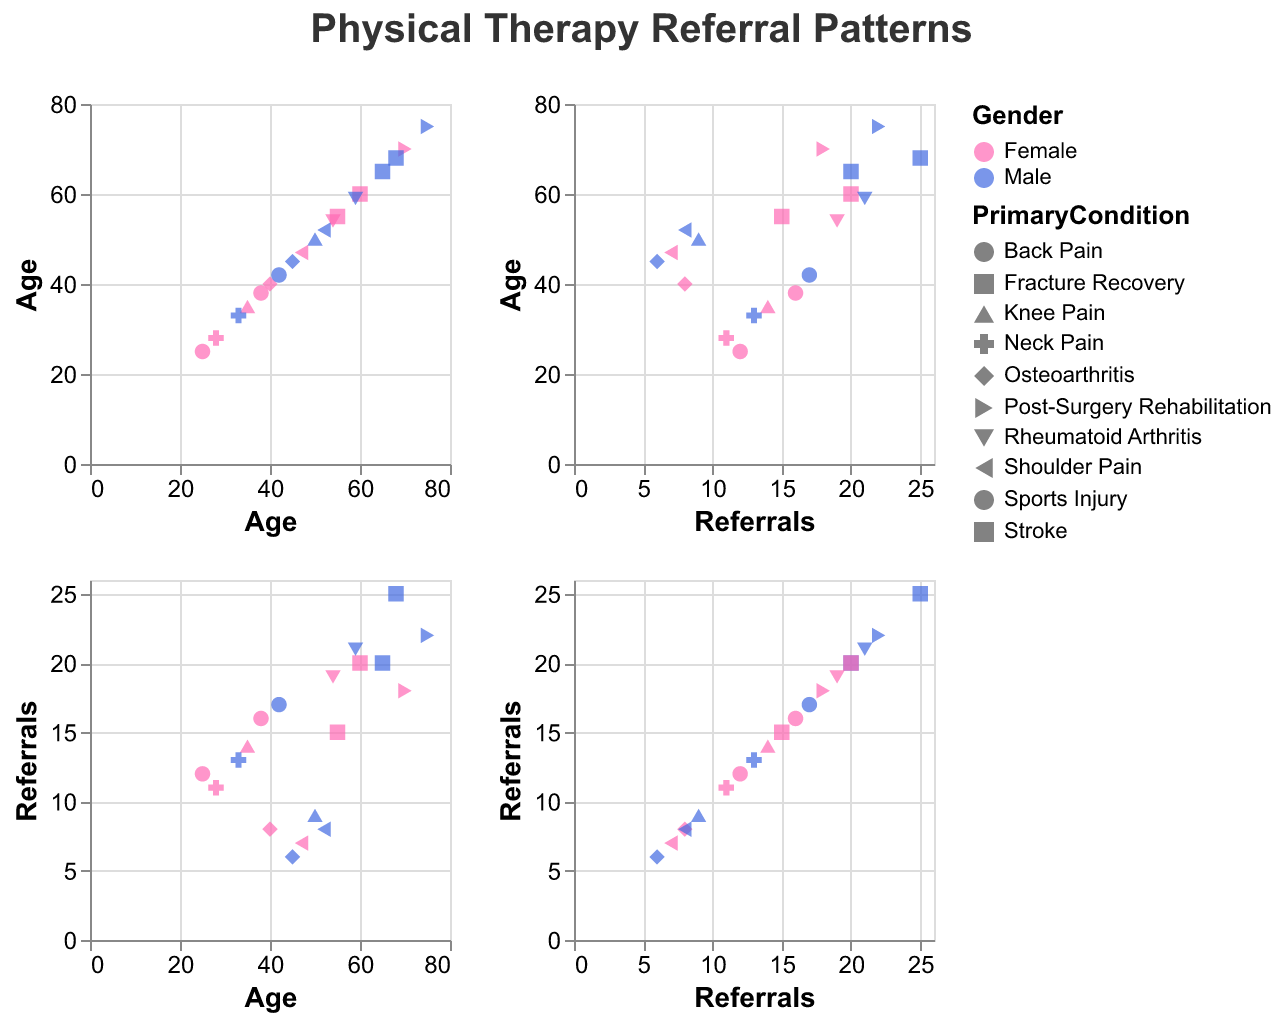What are the axis labels of the scatter plot matrix? The scatter plot matrix has axes labeled as "Age" and "Referrals" because the figure is created with these two variables to show the relationship between different features.
Answer: Age and Referrals How many data points are there in the scatter plot matrix? The data has 20 rows, which means there are 20 data points representing different individuals' ages, genders, primary conditions, and referrals.
Answer: 20 What is the title of the scatter plot matrix? The title of the scatter plot matrix can be seen at the top of the figure, which indicates what the visualization is about.
Answer: Physical Therapy Referral Patterns How is gender represented in the scatter plot matrix? Gender is represented by color in the scatter plot matrix. Females are in pink, and males are in blue.
Answer: Color: pink for Female, blue for Male What is the shape representing the "Back Pain" condition? Each primary medical condition has a unique shape in the scatter plot matrix, which can be identified by looking at the points associated with "Back Pain".
Answer: Point shape representing "Back Pain" What is the average age of patients with "Stroke"? To find the average age, locate the data points for "Stroke", sum their ages, and divide by the count: (55 + 65) / 2 = 60.
Answer: 60 Compare the number of referrals between males and females with "Knee Pain" Identify the data points for "Knee Pain" and compare the referral counts for male (9) and female (14).
Answer: Female has more referrals (14 vs. 9) What is the primary condition with the highest number of total referrals? Sum referrals for each condition and compare: Back Pain (22), Osteoarthritis (14), Stroke (35), Knee Pain (23), Post-Surgery Rehabilitation (40), Neck Pain (24), Shoulder Pain (15), Fracture Recovery (45), Sports Injury (33), Rheumatoid Arthritis (40). Fracture Recovery is the highest.
Answer: Fracture Recovery Do older patients generally have more referrals? Visually inspect the scatter plots arranged by age on one axis and referrals on the other to assess any visible trend between age and number of referrals.
Answer: Older patients appear to have more referrals 